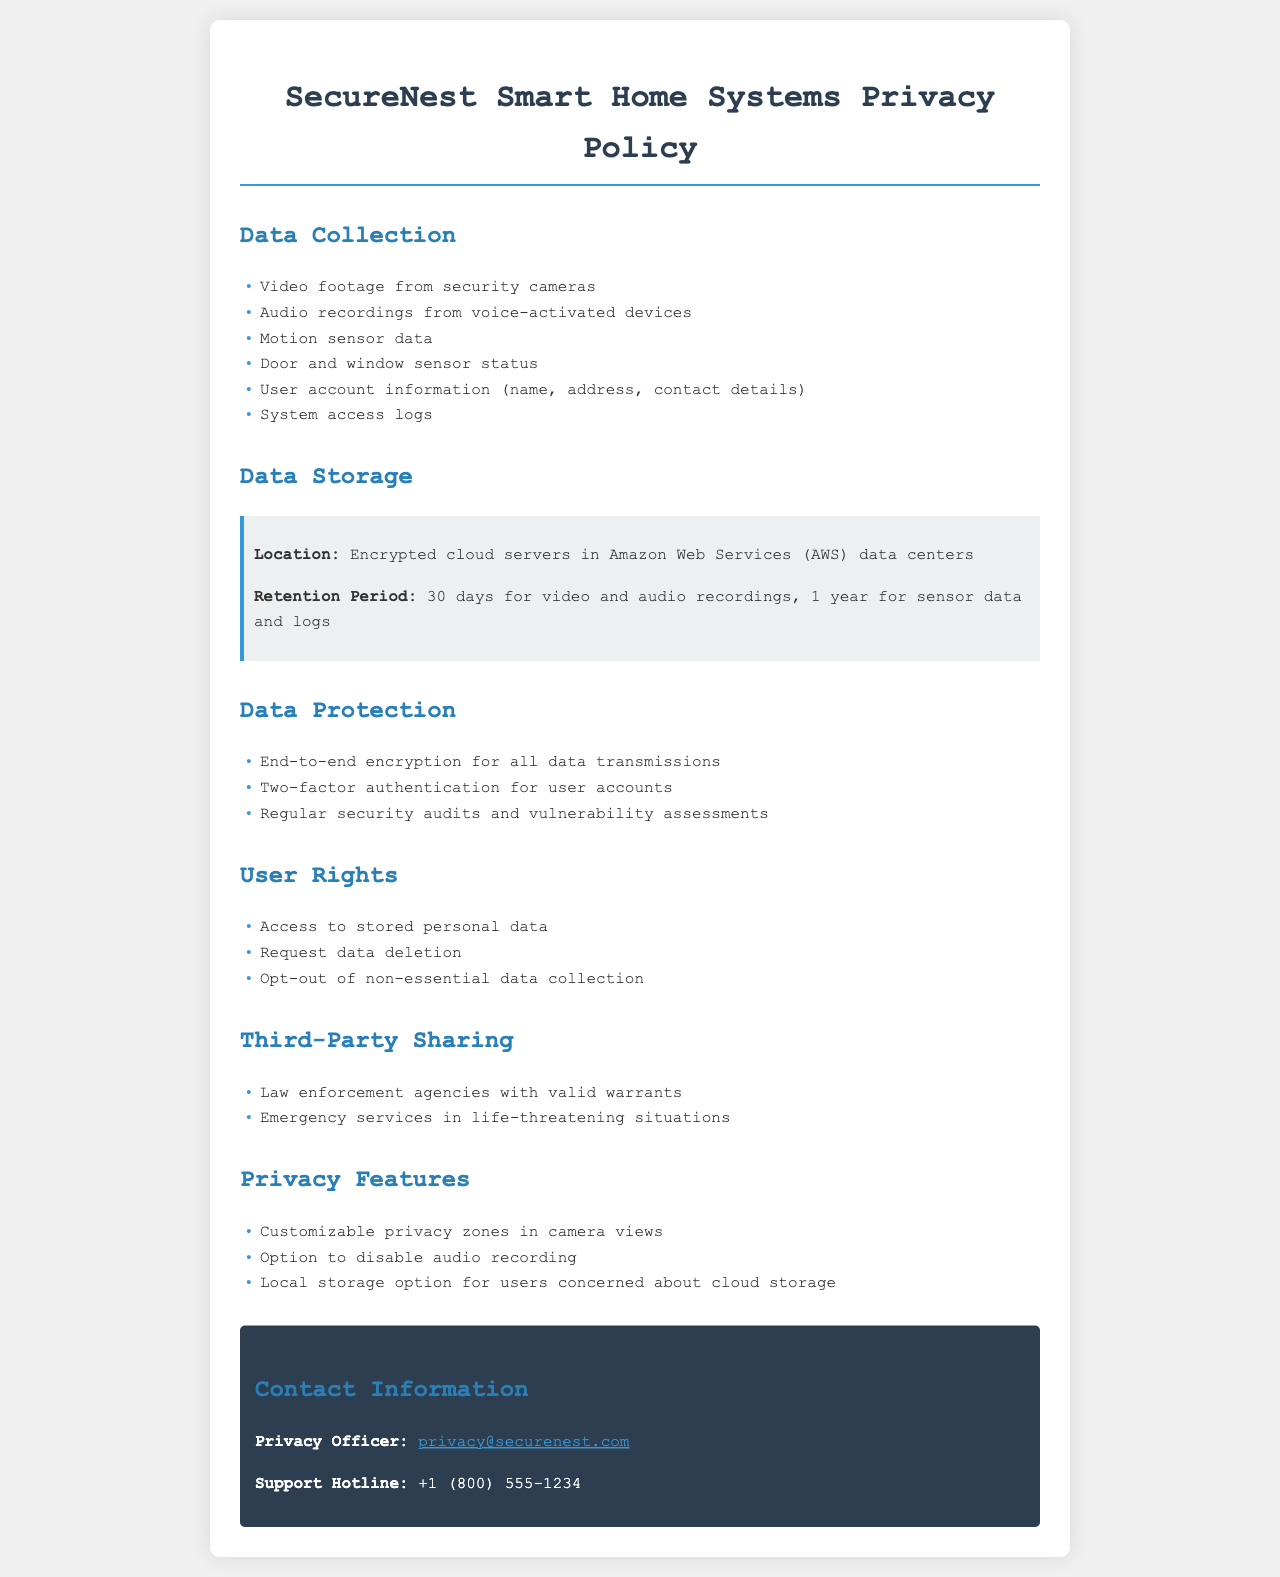What types of data are collected? The section titled "Data Collection" lists all the types of data collected by the system.
Answer: Video footage from security cameras, audio recordings from voice-activated devices, motion sensor data, door and window sensor status, user account information, system access logs What is the retention period for video recordings? The document specifies the retention period for video recordings in the "Data Storage" section.
Answer: 30 days Where are the data stored? The location of the data storage is mentioned under "Data Storage."
Answer: Encrypted cloud servers in Amazon Web Services (AWS) data centers What protections are implemented for data security? The "Data Protection" section outlines the various security measures taken to protect data.
Answer: End-to-end encryption for all data transmissions, two-factor authentication for user accounts, regular security audits and vulnerability assessments How long is sensor data retained? The retention period for sensor data is specified in the "Data Storage" section.
Answer: 1 year Who can access the data for law enforcement purposes? The "Third-Party Sharing" section explains the conditions under which data can be shared.
Answer: Law enforcement agencies with valid warrants What options are available for users concerned about cloud storage? The "Privacy Features" section provides options for users who might be worried about cloud storage.
Answer: Local storage option for users concerned about cloud storage What rights do users have regarding their personal data? The "User Rights" section lists the rights users have over their personal data.
Answer: Access to stored personal data, request data deletion, opt-out of non-essential data collection 